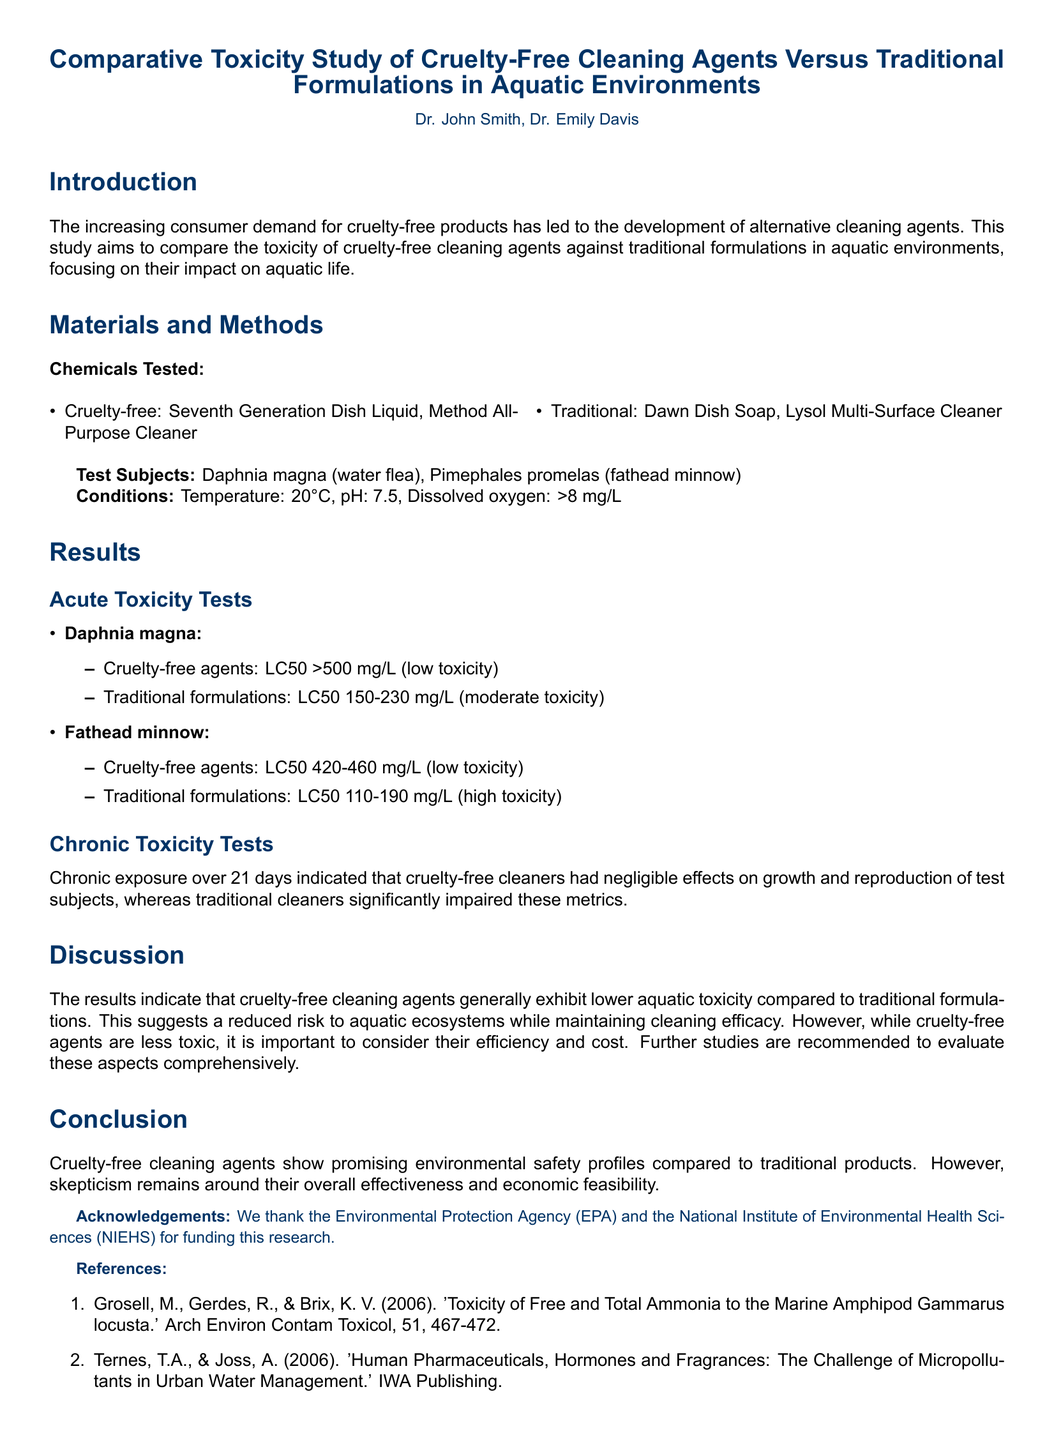What are the names of the cruelty-free cleaning agents tested? The document lists the cruelty-free agents tested in the study, which are Seventh Generation Dish Liquid and Method All-Purpose Cleaner.
Answer: Seventh Generation Dish Liquid, Method All-Purpose Cleaner What is the LC50 of traditional formulations for Daphnia magna? The LC50 for traditional formulations for Daphnia magna is specified in the results section, indicating a range of 150-230 mg/L.
Answer: 150-230 mg/L How long was the chronic exposure test conducted? The chronic exposure test duration is mentioned in the results section, indicating it was conducted over a period of 21 days.
Answer: 21 days What was the pH level during the tests? The pH level for the conditions set during the tests is provided in the materials and methods section, which is 7.5.
Answer: 7.5 Which agency funded the research? The acknowledgements section states that the Environmental Protection Agency (EPA) and the National Institute of Environmental Health Sciences (NIEHS) provided funding for the research.
Answer: Environmental Protection Agency (EPA), National Institute of Environmental Health Sciences (NIEHS) Did cruelty-free cleaning agents show significant effects on growth and reproduction in chronic tests? The discussion section notes that cruelty-free cleaners had negligible effects on growth and reproduction of test subjects, implying no significant effects were observed.
Answer: No What is the main conclusion drawn from the study? The conclusion summarizes the study's findings, indicating that cruelty-free cleaning agents show promising environmental safety profiles compared to traditional products.
Answer: Promising environmental safety profiles What were the test subjects used in the study? The materials and methods section specifies the test subjects used in the study, which are Daphnia magna and Pimephales promelas.
Answer: Daphnia magna, Pimephales promelas 